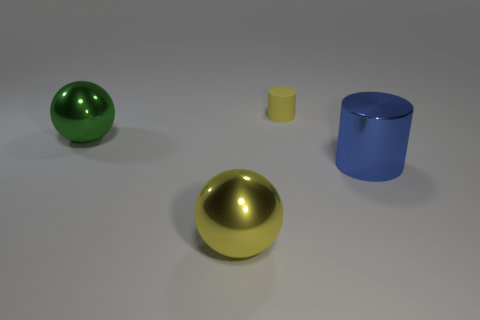Add 4 big shiny objects. How many objects exist? 8 Add 3 large green balls. How many large green balls exist? 4 Subtract 0 brown cubes. How many objects are left? 4 Subtract all tiny cyan balls. Subtract all large metallic objects. How many objects are left? 1 Add 2 yellow metallic things. How many yellow metallic things are left? 3 